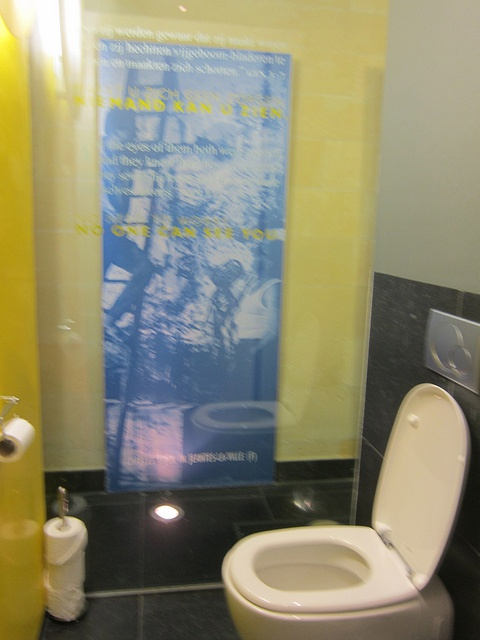Describe the objects in this image and their specific colors. I can see toilet in khaki, tan, and gray tones and toilet in khaki, gray, olive, and blue tones in this image. 